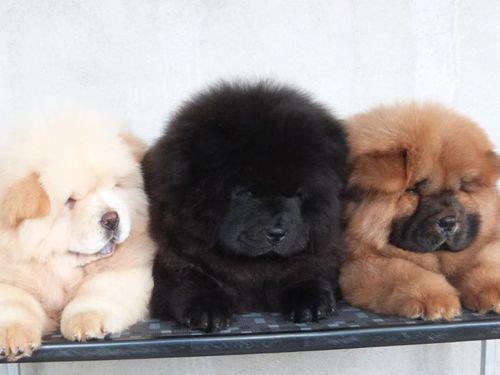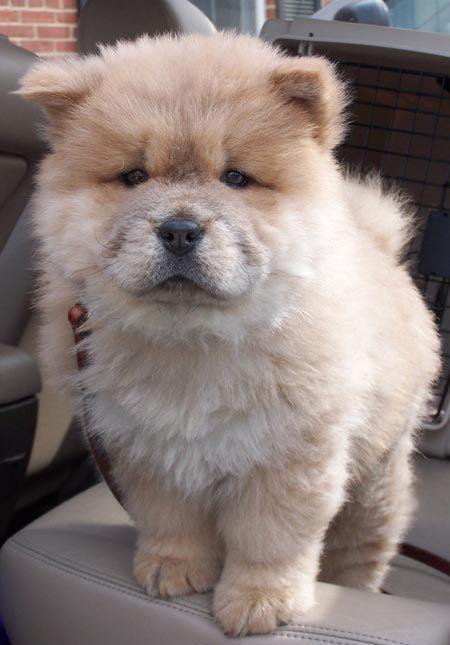The first image is the image on the left, the second image is the image on the right. Given the left and right images, does the statement "A total of three dogs are shown in the foreground of the combined images." hold true? Answer yes or no. No. The first image is the image on the left, the second image is the image on the right. Given the left and right images, does the statement "One of the dogs is standing and looking toward the camera." hold true? Answer yes or no. Yes. 